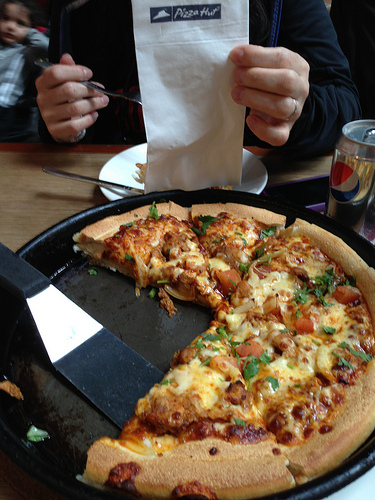Please provide the bounding box coordinate of the region this sentence describes: Person's hand wearing a wedding ring. The hand wearing a wedding ring can be found in the region approximately marked by the coordinates [0.58, 0.09, 0.74, 0.3]. 